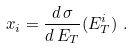Convert formula to latex. <formula><loc_0><loc_0><loc_500><loc_500>x _ { i } = \frac { d \, \sigma } { d \, E _ { T } } ( E _ { T } ^ { i } ) \ .</formula> 